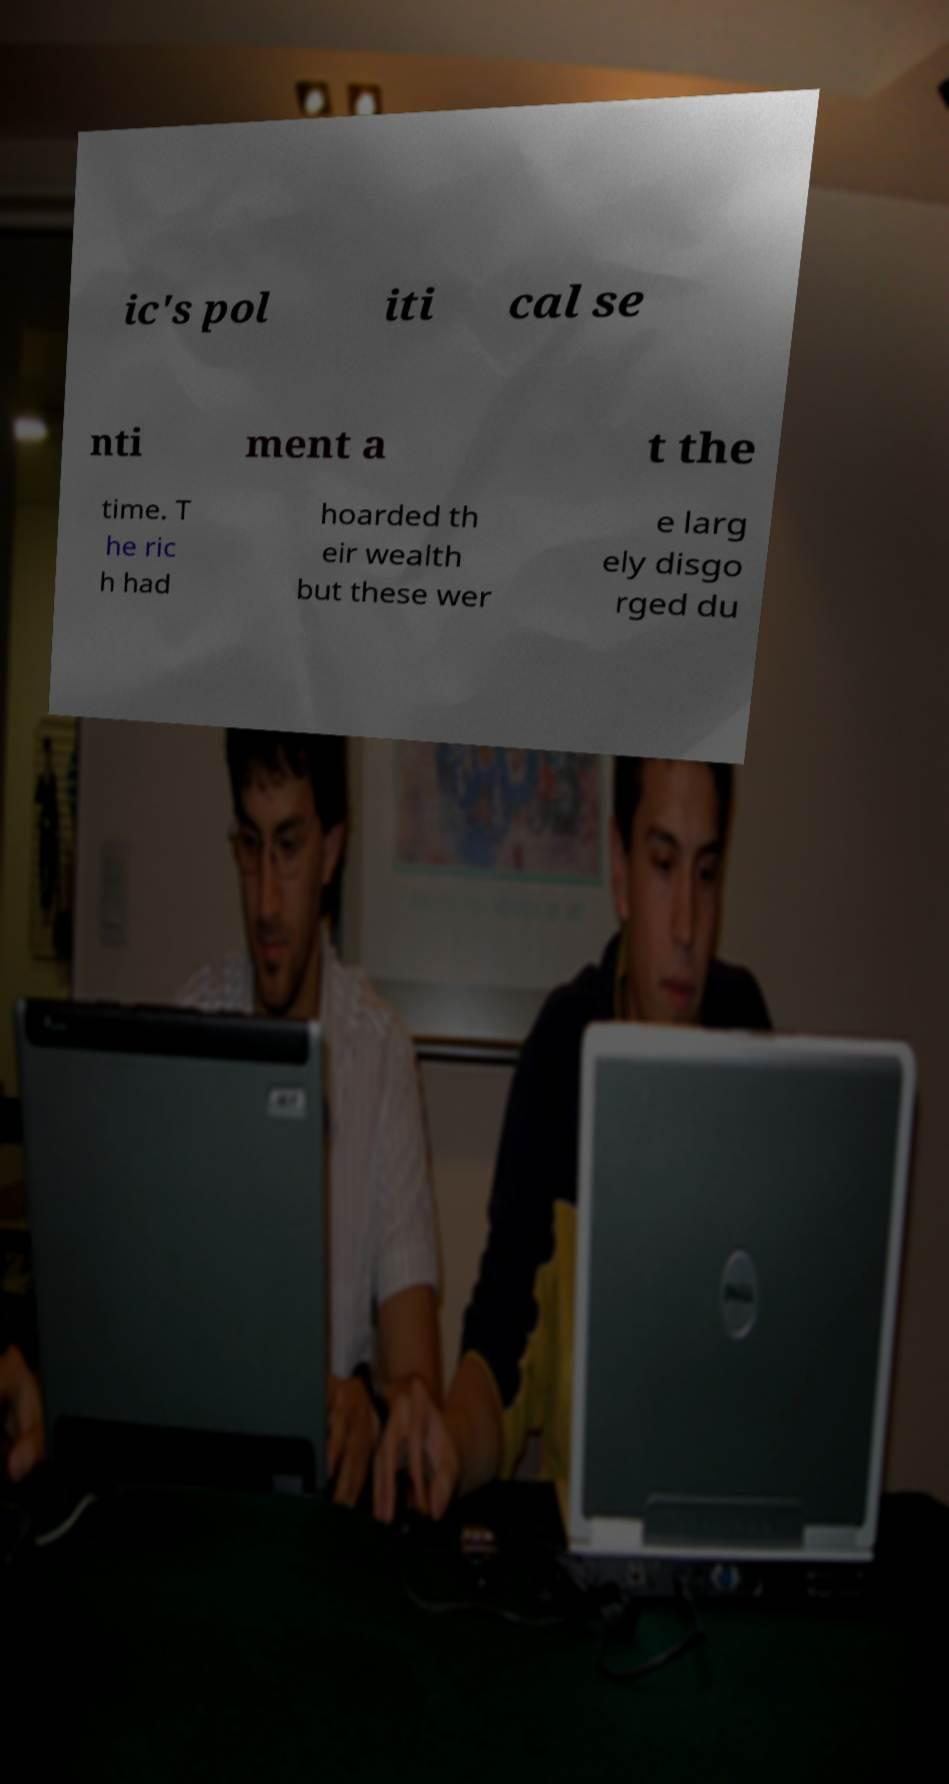Could you extract and type out the text from this image? ic's pol iti cal se nti ment a t the time. T he ric h had hoarded th eir wealth but these wer e larg ely disgo rged du 